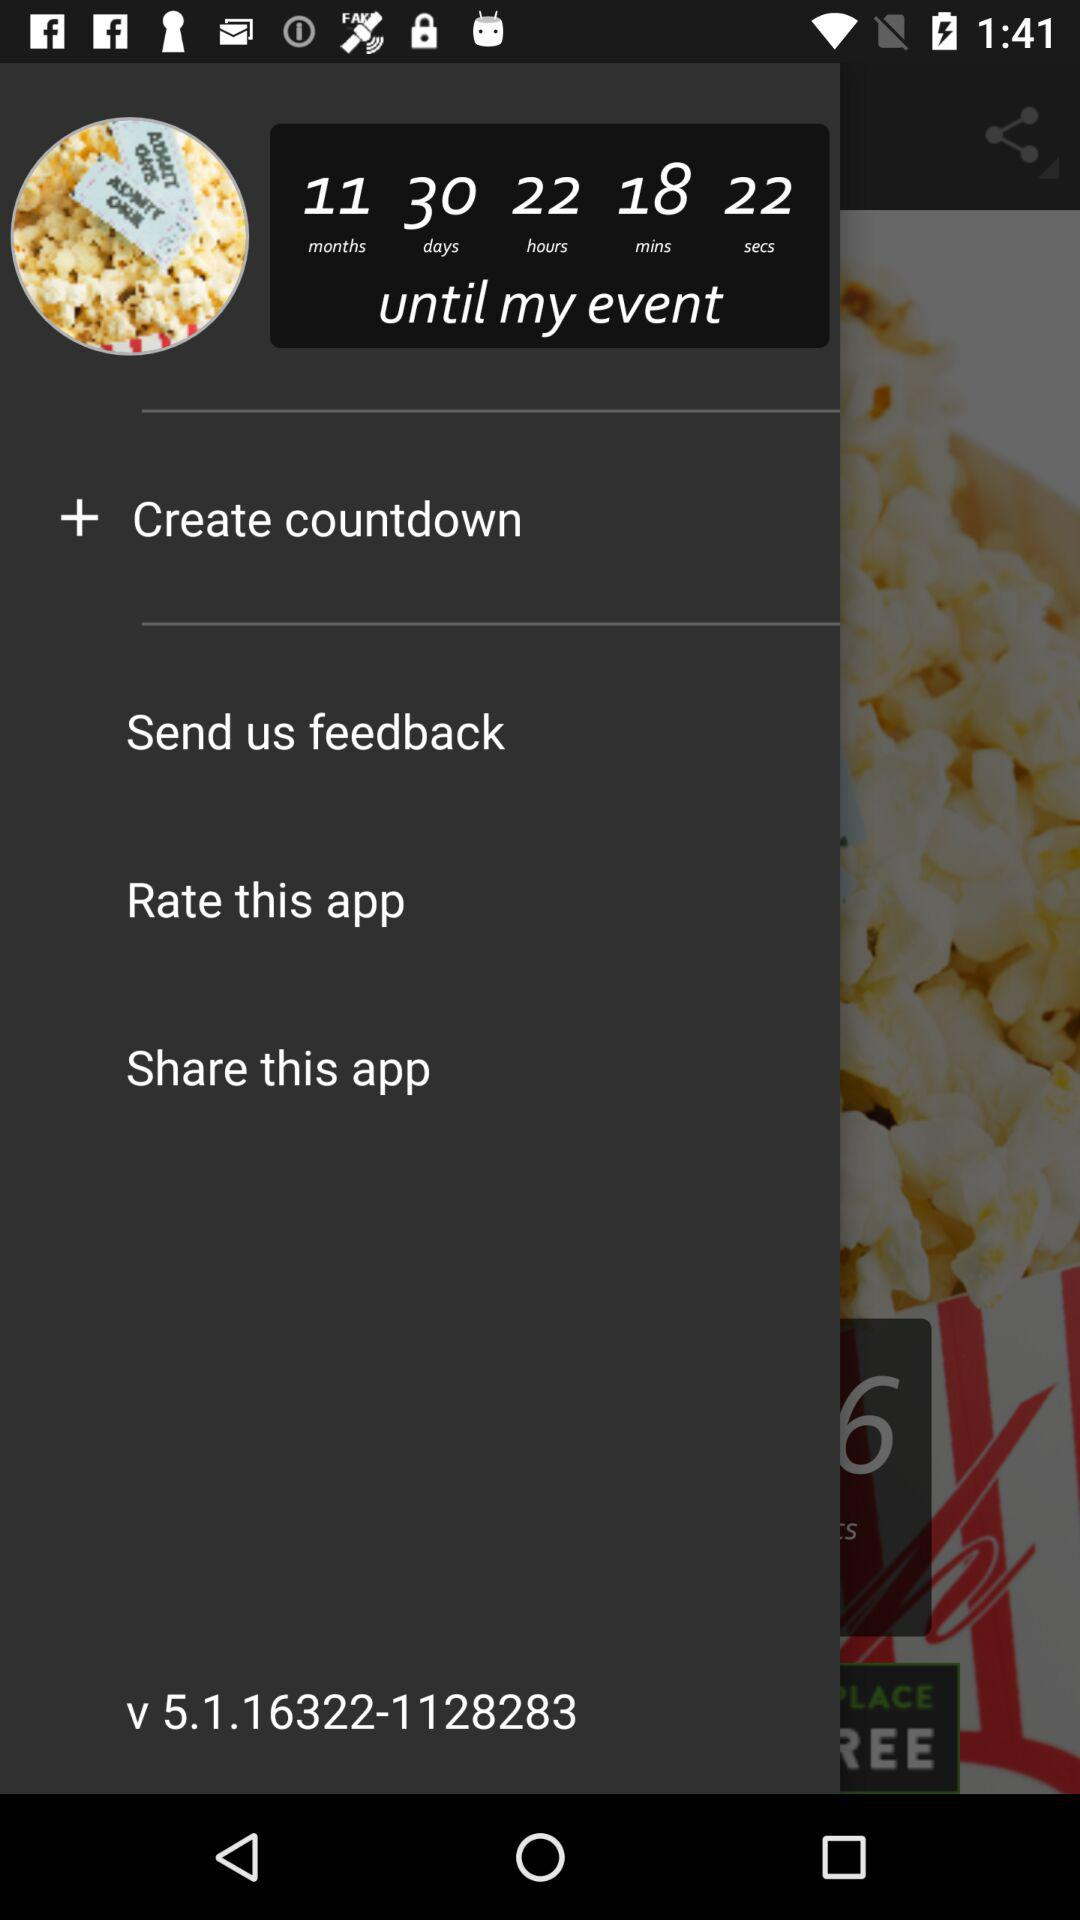What is the version number? The version number is v 5.1.16322-1128283. 